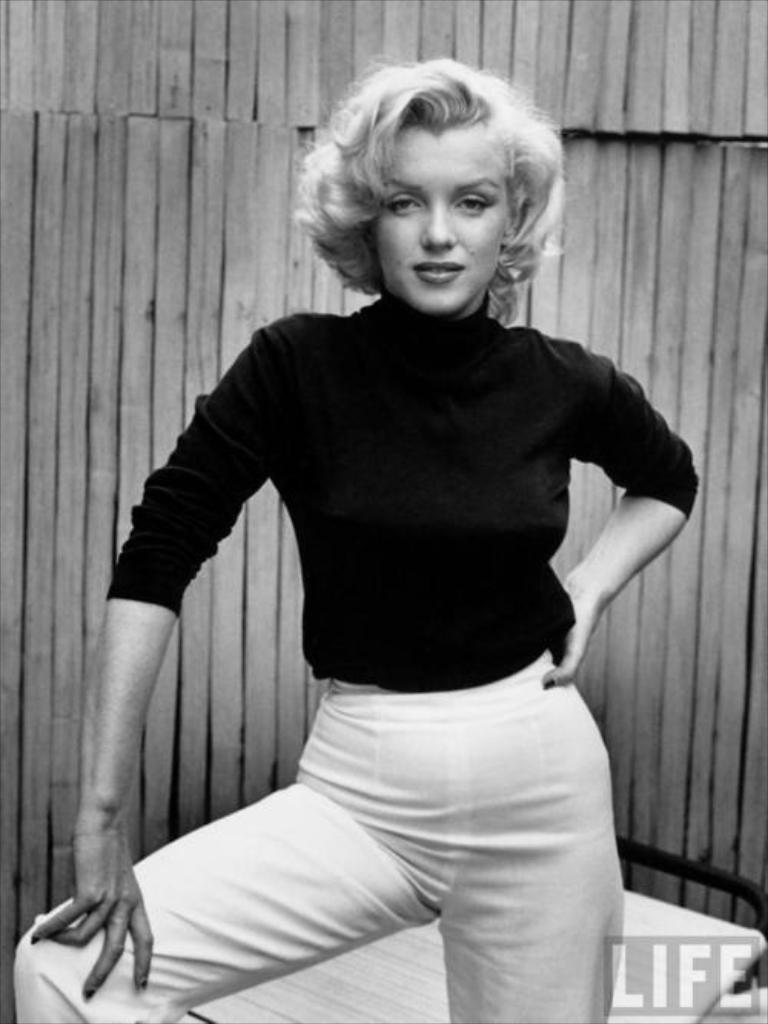What is the color scheme of the image? The image is black and white. Who is present in the image? There is a woman in the image. What can be seen in the background of the image? There is a wooden wall in the background of the image. Where is the text located in the image? The text is in the bottom left of the image. What type of crown is the frog wearing in the image? There is no frog or crown present in the image. 